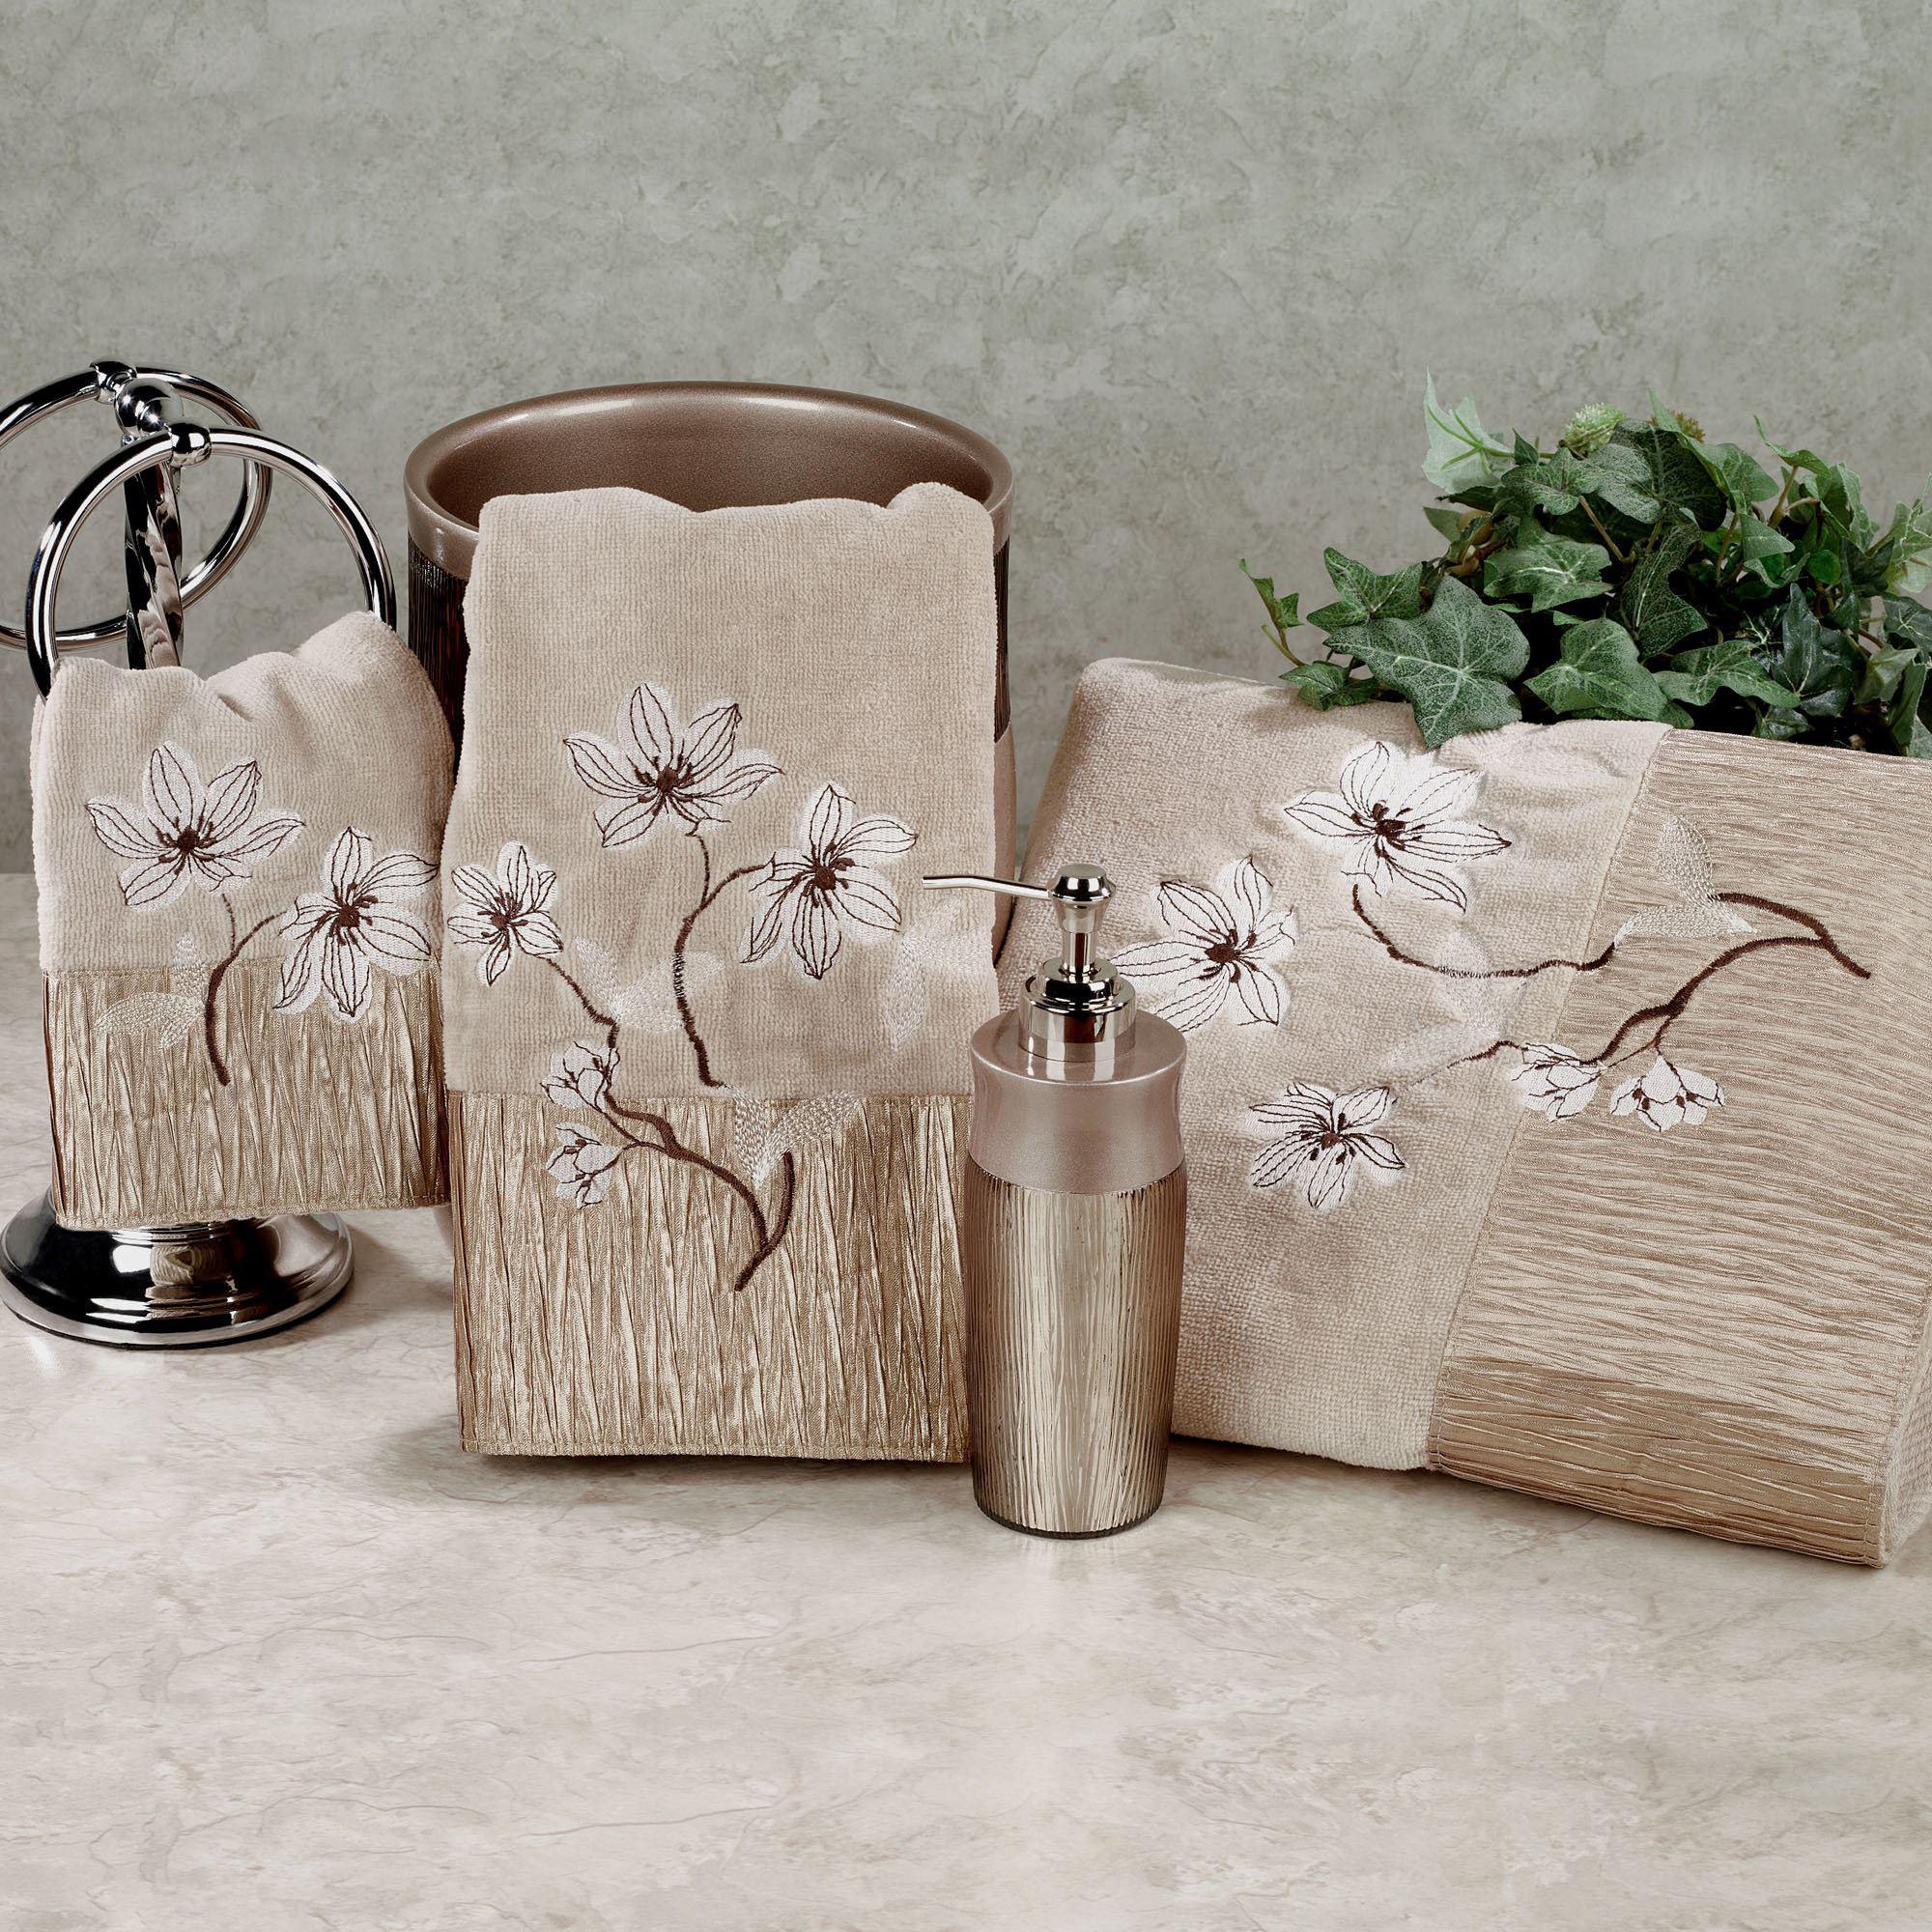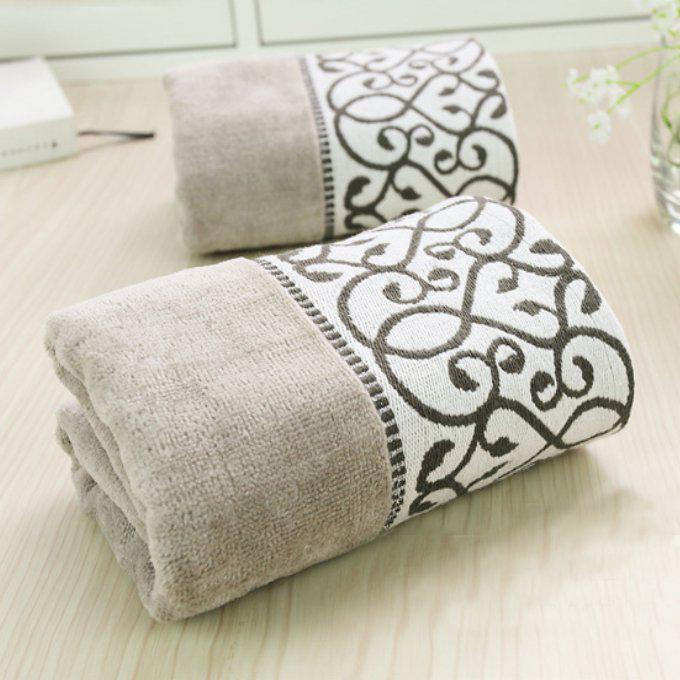The first image is the image on the left, the second image is the image on the right. Given the left and right images, does the statement "There are at least two very light brown towels with its top half white with S looking vines sewn into it." hold true? Answer yes or no. Yes. 